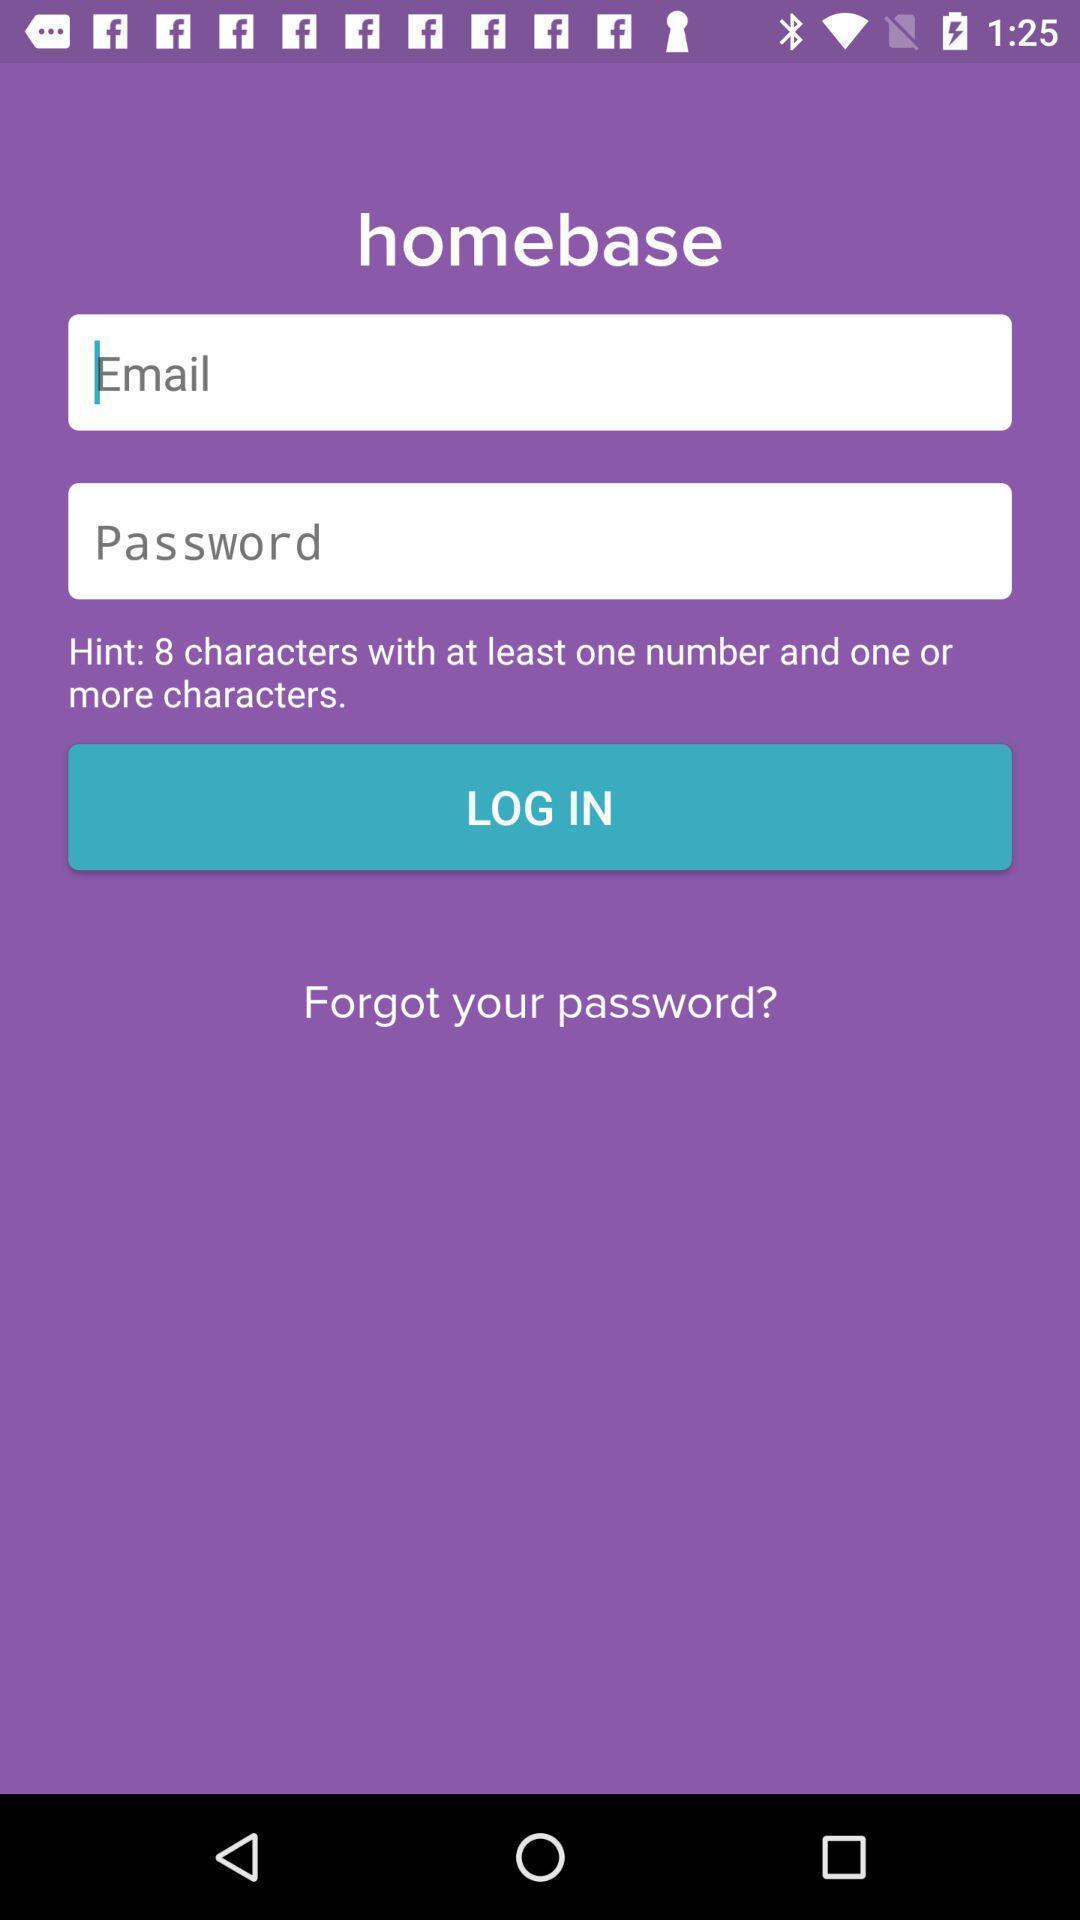What is the overall content of this screenshot? Login page for an application. 